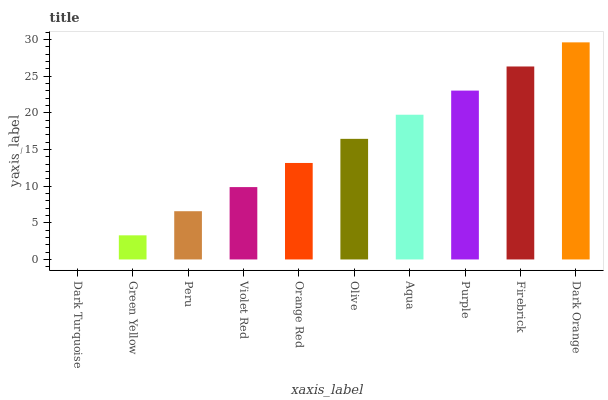Is Dark Turquoise the minimum?
Answer yes or no. Yes. Is Dark Orange the maximum?
Answer yes or no. Yes. Is Green Yellow the minimum?
Answer yes or no. No. Is Green Yellow the maximum?
Answer yes or no. No. Is Green Yellow greater than Dark Turquoise?
Answer yes or no. Yes. Is Dark Turquoise less than Green Yellow?
Answer yes or no. Yes. Is Dark Turquoise greater than Green Yellow?
Answer yes or no. No. Is Green Yellow less than Dark Turquoise?
Answer yes or no. No. Is Olive the high median?
Answer yes or no. Yes. Is Orange Red the low median?
Answer yes or no. Yes. Is Dark Orange the high median?
Answer yes or no. No. Is Peru the low median?
Answer yes or no. No. 